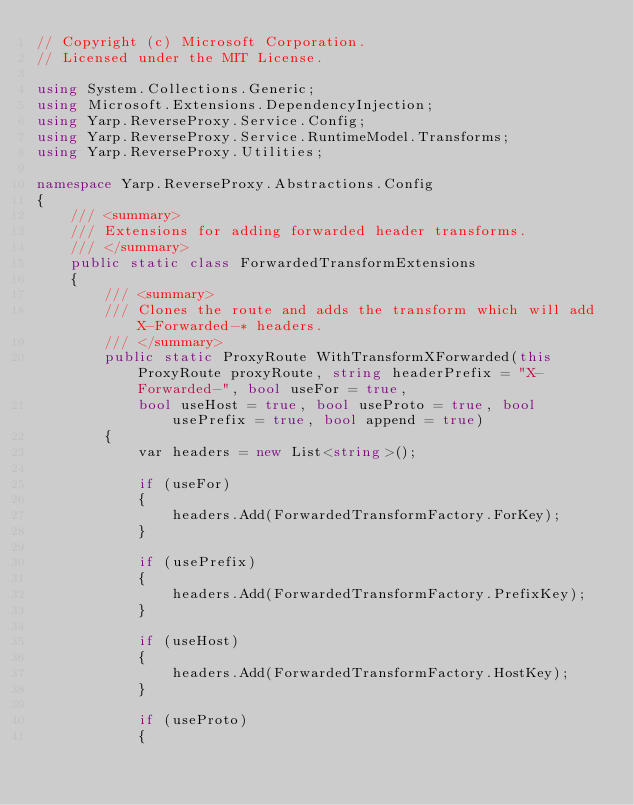<code> <loc_0><loc_0><loc_500><loc_500><_C#_>// Copyright (c) Microsoft Corporation.
// Licensed under the MIT License.

using System.Collections.Generic;
using Microsoft.Extensions.DependencyInjection;
using Yarp.ReverseProxy.Service.Config;
using Yarp.ReverseProxy.Service.RuntimeModel.Transforms;
using Yarp.ReverseProxy.Utilities;

namespace Yarp.ReverseProxy.Abstractions.Config
{
    /// <summary>
    /// Extensions for adding forwarded header transforms.
    /// </summary>
    public static class ForwardedTransformExtensions
    {
        /// <summary>
        /// Clones the route and adds the transform which will add X-Forwarded-* headers.
        /// </summary>
        public static ProxyRoute WithTransformXForwarded(this ProxyRoute proxyRoute, string headerPrefix = "X-Forwarded-", bool useFor = true,
            bool useHost = true, bool useProto = true, bool usePrefix = true, bool append = true)
        {
            var headers = new List<string>();

            if (useFor)
            {
                headers.Add(ForwardedTransformFactory.ForKey);
            }

            if (usePrefix)
            {
                headers.Add(ForwardedTransformFactory.PrefixKey);
            }

            if (useHost)
            {
                headers.Add(ForwardedTransformFactory.HostKey);
            }

            if (useProto)
            {</code> 